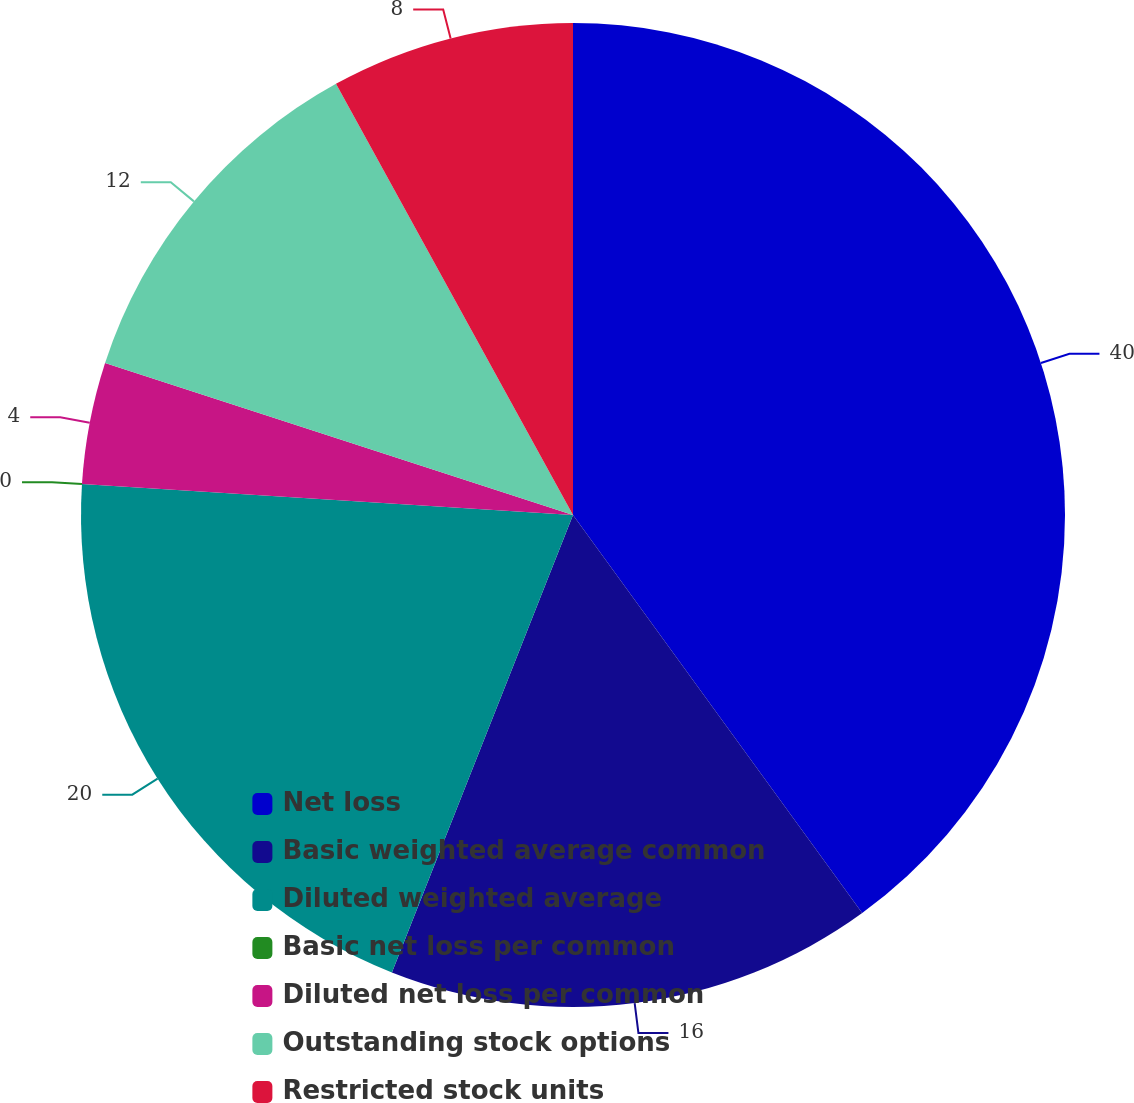<chart> <loc_0><loc_0><loc_500><loc_500><pie_chart><fcel>Net loss<fcel>Basic weighted average common<fcel>Diluted weighted average<fcel>Basic net loss per common<fcel>Diluted net loss per common<fcel>Outstanding stock options<fcel>Restricted stock units<nl><fcel>40.0%<fcel>16.0%<fcel>20.0%<fcel>0.0%<fcel>4.0%<fcel>12.0%<fcel>8.0%<nl></chart> 